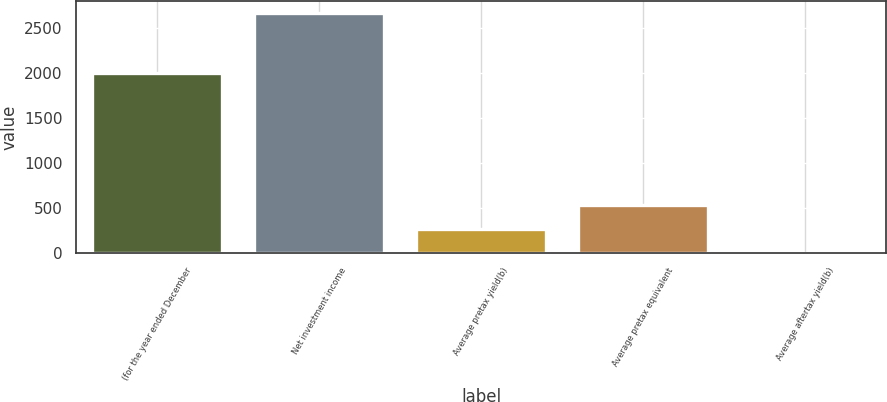Convert chart. <chart><loc_0><loc_0><loc_500><loc_500><bar_chart><fcel>(for the year ended December<fcel>Net investment income<fcel>Average pretax yield(b)<fcel>Average pretax equivalent<fcel>Average aftertax yield(b)<nl><fcel>2004<fcel>2663<fcel>269.63<fcel>535.56<fcel>3.7<nl></chart> 